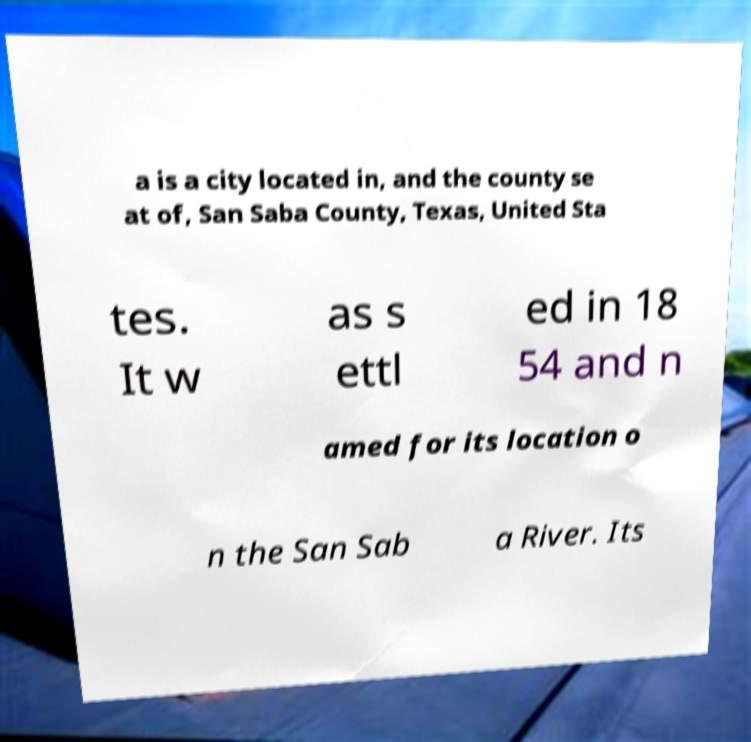Can you read and provide the text displayed in the image?This photo seems to have some interesting text. Can you extract and type it out for me? a is a city located in, and the county se at of, San Saba County, Texas, United Sta tes. It w as s ettl ed in 18 54 and n amed for its location o n the San Sab a River. Its 